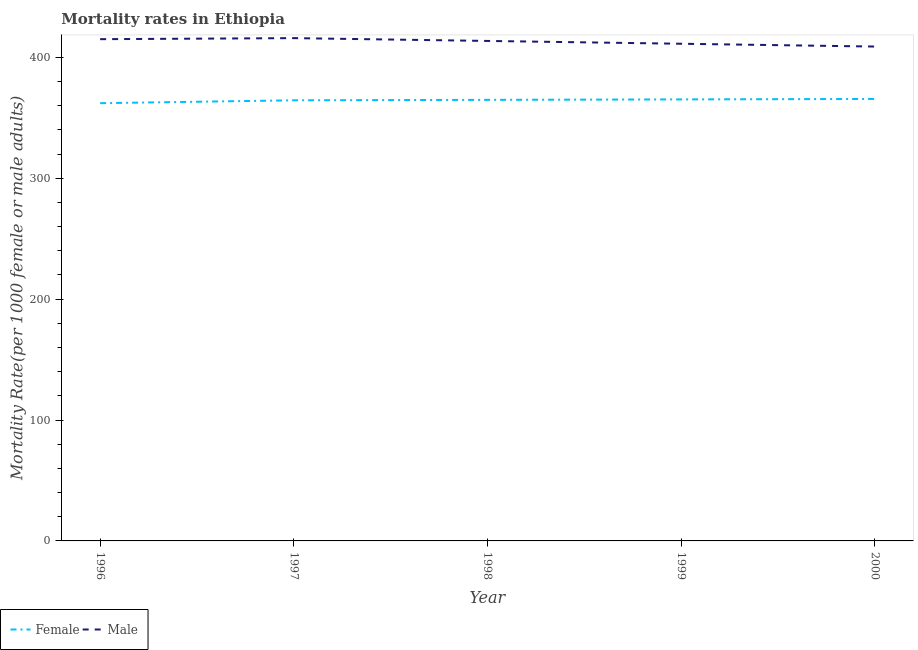How many different coloured lines are there?
Your answer should be compact. 2. Does the line corresponding to female mortality rate intersect with the line corresponding to male mortality rate?
Your answer should be very brief. No. Is the number of lines equal to the number of legend labels?
Offer a terse response. Yes. What is the female mortality rate in 1997?
Your response must be concise. 364.42. Across all years, what is the maximum male mortality rate?
Provide a short and direct response. 415.84. Across all years, what is the minimum female mortality rate?
Your answer should be very brief. 362.03. In which year was the male mortality rate maximum?
Offer a terse response. 1997. What is the total male mortality rate in the graph?
Offer a terse response. 2064.4. What is the difference between the male mortality rate in 1997 and that in 1998?
Make the answer very short. 2.32. What is the difference between the female mortality rate in 1999 and the male mortality rate in 1997?
Keep it short and to the point. -50.68. What is the average male mortality rate per year?
Your answer should be very brief. 412.88. In the year 1999, what is the difference between the female mortality rate and male mortality rate?
Offer a very short reply. -46.03. What is the ratio of the female mortality rate in 1996 to that in 2000?
Offer a very short reply. 0.99. Is the female mortality rate in 1997 less than that in 2000?
Your answer should be compact. Yes. Is the difference between the female mortality rate in 1997 and 1999 greater than the difference between the male mortality rate in 1997 and 1999?
Provide a short and direct response. No. What is the difference between the highest and the second highest male mortality rate?
Offer a terse response. 0.87. What is the difference between the highest and the lowest male mortality rate?
Your answer should be very brief. 6.97. In how many years, is the female mortality rate greater than the average female mortality rate taken over all years?
Offer a very short reply. 4. Does the female mortality rate monotonically increase over the years?
Make the answer very short. Yes. Is the female mortality rate strictly greater than the male mortality rate over the years?
Your response must be concise. No. How many years are there in the graph?
Keep it short and to the point. 5. What is the difference between two consecutive major ticks on the Y-axis?
Your answer should be very brief. 100. How many legend labels are there?
Ensure brevity in your answer.  2. What is the title of the graph?
Your response must be concise. Mortality rates in Ethiopia. What is the label or title of the Y-axis?
Keep it short and to the point. Mortality Rate(per 1000 female or male adults). What is the Mortality Rate(per 1000 female or male adults) of Female in 1996?
Offer a terse response. 362.03. What is the Mortality Rate(per 1000 female or male adults) of Male in 1996?
Your response must be concise. 414.98. What is the Mortality Rate(per 1000 female or male adults) in Female in 1997?
Offer a very short reply. 364.42. What is the Mortality Rate(per 1000 female or male adults) in Male in 1997?
Your answer should be compact. 415.84. What is the Mortality Rate(per 1000 female or male adults) in Female in 1998?
Your response must be concise. 364.79. What is the Mortality Rate(per 1000 female or male adults) of Male in 1998?
Give a very brief answer. 413.52. What is the Mortality Rate(per 1000 female or male adults) in Female in 1999?
Your answer should be very brief. 365.16. What is the Mortality Rate(per 1000 female or male adults) in Male in 1999?
Your response must be concise. 411.19. What is the Mortality Rate(per 1000 female or male adults) of Female in 2000?
Your response must be concise. 365.54. What is the Mortality Rate(per 1000 female or male adults) in Male in 2000?
Your answer should be compact. 408.87. Across all years, what is the maximum Mortality Rate(per 1000 female or male adults) in Female?
Make the answer very short. 365.54. Across all years, what is the maximum Mortality Rate(per 1000 female or male adults) of Male?
Your answer should be compact. 415.84. Across all years, what is the minimum Mortality Rate(per 1000 female or male adults) of Female?
Offer a very short reply. 362.03. Across all years, what is the minimum Mortality Rate(per 1000 female or male adults) in Male?
Offer a very short reply. 408.87. What is the total Mortality Rate(per 1000 female or male adults) of Female in the graph?
Your answer should be compact. 1821.94. What is the total Mortality Rate(per 1000 female or male adults) in Male in the graph?
Make the answer very short. 2064.4. What is the difference between the Mortality Rate(per 1000 female or male adults) of Female in 1996 and that in 1997?
Offer a very short reply. -2.39. What is the difference between the Mortality Rate(per 1000 female or male adults) in Male in 1996 and that in 1997?
Your answer should be very brief. -0.87. What is the difference between the Mortality Rate(per 1000 female or male adults) in Female in 1996 and that in 1998?
Ensure brevity in your answer.  -2.76. What is the difference between the Mortality Rate(per 1000 female or male adults) of Male in 1996 and that in 1998?
Make the answer very short. 1.46. What is the difference between the Mortality Rate(per 1000 female or male adults) of Female in 1996 and that in 1999?
Your answer should be compact. -3.13. What is the difference between the Mortality Rate(per 1000 female or male adults) in Male in 1996 and that in 1999?
Keep it short and to the point. 3.78. What is the difference between the Mortality Rate(per 1000 female or male adults) of Female in 1996 and that in 2000?
Ensure brevity in your answer.  -3.51. What is the difference between the Mortality Rate(per 1000 female or male adults) in Male in 1996 and that in 2000?
Offer a very short reply. 6.11. What is the difference between the Mortality Rate(per 1000 female or male adults) of Female in 1997 and that in 1998?
Your answer should be very brief. -0.37. What is the difference between the Mortality Rate(per 1000 female or male adults) of Male in 1997 and that in 1998?
Keep it short and to the point. 2.32. What is the difference between the Mortality Rate(per 1000 female or male adults) in Female in 1997 and that in 1999?
Your answer should be very brief. -0.75. What is the difference between the Mortality Rate(per 1000 female or male adults) of Male in 1997 and that in 1999?
Offer a terse response. 4.65. What is the difference between the Mortality Rate(per 1000 female or male adults) in Female in 1997 and that in 2000?
Make the answer very short. -1.12. What is the difference between the Mortality Rate(per 1000 female or male adults) of Male in 1997 and that in 2000?
Your answer should be very brief. 6.97. What is the difference between the Mortality Rate(per 1000 female or male adults) in Female in 1998 and that in 1999?
Your answer should be very brief. -0.37. What is the difference between the Mortality Rate(per 1000 female or male adults) in Male in 1998 and that in 1999?
Your response must be concise. 2.32. What is the difference between the Mortality Rate(per 1000 female or male adults) of Female in 1998 and that in 2000?
Your answer should be compact. -0.75. What is the difference between the Mortality Rate(per 1000 female or male adults) in Male in 1998 and that in 2000?
Provide a short and direct response. 4.65. What is the difference between the Mortality Rate(per 1000 female or male adults) in Female in 1999 and that in 2000?
Your response must be concise. -0.37. What is the difference between the Mortality Rate(per 1000 female or male adults) in Male in 1999 and that in 2000?
Offer a very short reply. 2.32. What is the difference between the Mortality Rate(per 1000 female or male adults) of Female in 1996 and the Mortality Rate(per 1000 female or male adults) of Male in 1997?
Offer a terse response. -53.81. What is the difference between the Mortality Rate(per 1000 female or male adults) in Female in 1996 and the Mortality Rate(per 1000 female or male adults) in Male in 1998?
Offer a very short reply. -51.49. What is the difference between the Mortality Rate(per 1000 female or male adults) of Female in 1996 and the Mortality Rate(per 1000 female or male adults) of Male in 1999?
Ensure brevity in your answer.  -49.16. What is the difference between the Mortality Rate(per 1000 female or male adults) in Female in 1996 and the Mortality Rate(per 1000 female or male adults) in Male in 2000?
Ensure brevity in your answer.  -46.84. What is the difference between the Mortality Rate(per 1000 female or male adults) in Female in 1997 and the Mortality Rate(per 1000 female or male adults) in Male in 1998?
Your answer should be compact. -49.1. What is the difference between the Mortality Rate(per 1000 female or male adults) of Female in 1997 and the Mortality Rate(per 1000 female or male adults) of Male in 1999?
Provide a short and direct response. -46.78. What is the difference between the Mortality Rate(per 1000 female or male adults) in Female in 1997 and the Mortality Rate(per 1000 female or male adults) in Male in 2000?
Provide a succinct answer. -44.45. What is the difference between the Mortality Rate(per 1000 female or male adults) in Female in 1998 and the Mortality Rate(per 1000 female or male adults) in Male in 1999?
Offer a terse response. -46.4. What is the difference between the Mortality Rate(per 1000 female or male adults) of Female in 1998 and the Mortality Rate(per 1000 female or male adults) of Male in 2000?
Provide a succinct answer. -44.08. What is the difference between the Mortality Rate(per 1000 female or male adults) in Female in 1999 and the Mortality Rate(per 1000 female or male adults) in Male in 2000?
Ensure brevity in your answer.  -43.71. What is the average Mortality Rate(per 1000 female or male adults) in Female per year?
Offer a terse response. 364.39. What is the average Mortality Rate(per 1000 female or male adults) in Male per year?
Your answer should be compact. 412.88. In the year 1996, what is the difference between the Mortality Rate(per 1000 female or male adults) in Female and Mortality Rate(per 1000 female or male adults) in Male?
Offer a very short reply. -52.95. In the year 1997, what is the difference between the Mortality Rate(per 1000 female or male adults) of Female and Mortality Rate(per 1000 female or male adults) of Male?
Your answer should be compact. -51.42. In the year 1998, what is the difference between the Mortality Rate(per 1000 female or male adults) in Female and Mortality Rate(per 1000 female or male adults) in Male?
Provide a succinct answer. -48.73. In the year 1999, what is the difference between the Mortality Rate(per 1000 female or male adults) of Female and Mortality Rate(per 1000 female or male adults) of Male?
Provide a short and direct response. -46.03. In the year 2000, what is the difference between the Mortality Rate(per 1000 female or male adults) in Female and Mortality Rate(per 1000 female or male adults) in Male?
Provide a succinct answer. -43.33. What is the ratio of the Mortality Rate(per 1000 female or male adults) of Female in 1996 to that in 1997?
Your response must be concise. 0.99. What is the ratio of the Mortality Rate(per 1000 female or male adults) of Male in 1996 to that in 1997?
Provide a succinct answer. 1. What is the ratio of the Mortality Rate(per 1000 female or male adults) in Female in 1996 to that in 1999?
Make the answer very short. 0.99. What is the ratio of the Mortality Rate(per 1000 female or male adults) of Male in 1996 to that in 1999?
Your answer should be compact. 1.01. What is the ratio of the Mortality Rate(per 1000 female or male adults) in Female in 1996 to that in 2000?
Provide a succinct answer. 0.99. What is the ratio of the Mortality Rate(per 1000 female or male adults) of Male in 1996 to that in 2000?
Provide a succinct answer. 1.01. What is the ratio of the Mortality Rate(per 1000 female or male adults) of Male in 1997 to that in 1998?
Ensure brevity in your answer.  1.01. What is the ratio of the Mortality Rate(per 1000 female or male adults) in Male in 1997 to that in 1999?
Provide a short and direct response. 1.01. What is the ratio of the Mortality Rate(per 1000 female or male adults) of Female in 1997 to that in 2000?
Your answer should be very brief. 1. What is the ratio of the Mortality Rate(per 1000 female or male adults) in Male in 1997 to that in 2000?
Give a very brief answer. 1.02. What is the ratio of the Mortality Rate(per 1000 female or male adults) of Female in 1998 to that in 1999?
Your response must be concise. 1. What is the ratio of the Mortality Rate(per 1000 female or male adults) of Female in 1998 to that in 2000?
Make the answer very short. 1. What is the ratio of the Mortality Rate(per 1000 female or male adults) of Male in 1998 to that in 2000?
Provide a short and direct response. 1.01. What is the ratio of the Mortality Rate(per 1000 female or male adults) in Female in 1999 to that in 2000?
Ensure brevity in your answer.  1. What is the difference between the highest and the second highest Mortality Rate(per 1000 female or male adults) of Female?
Provide a succinct answer. 0.37. What is the difference between the highest and the second highest Mortality Rate(per 1000 female or male adults) in Male?
Make the answer very short. 0.87. What is the difference between the highest and the lowest Mortality Rate(per 1000 female or male adults) in Female?
Offer a terse response. 3.51. What is the difference between the highest and the lowest Mortality Rate(per 1000 female or male adults) in Male?
Keep it short and to the point. 6.97. 